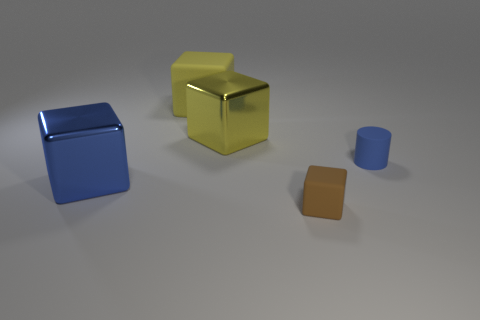Subtract all gray blocks. Subtract all gray balls. How many blocks are left? 4 Add 3 big yellow matte blocks. How many objects exist? 8 Subtract all cylinders. How many objects are left? 4 Add 3 yellow cubes. How many yellow cubes exist? 5 Subtract 0 cyan balls. How many objects are left? 5 Subtract all blue things. Subtract all brown cubes. How many objects are left? 2 Add 4 blue rubber objects. How many blue rubber objects are left? 5 